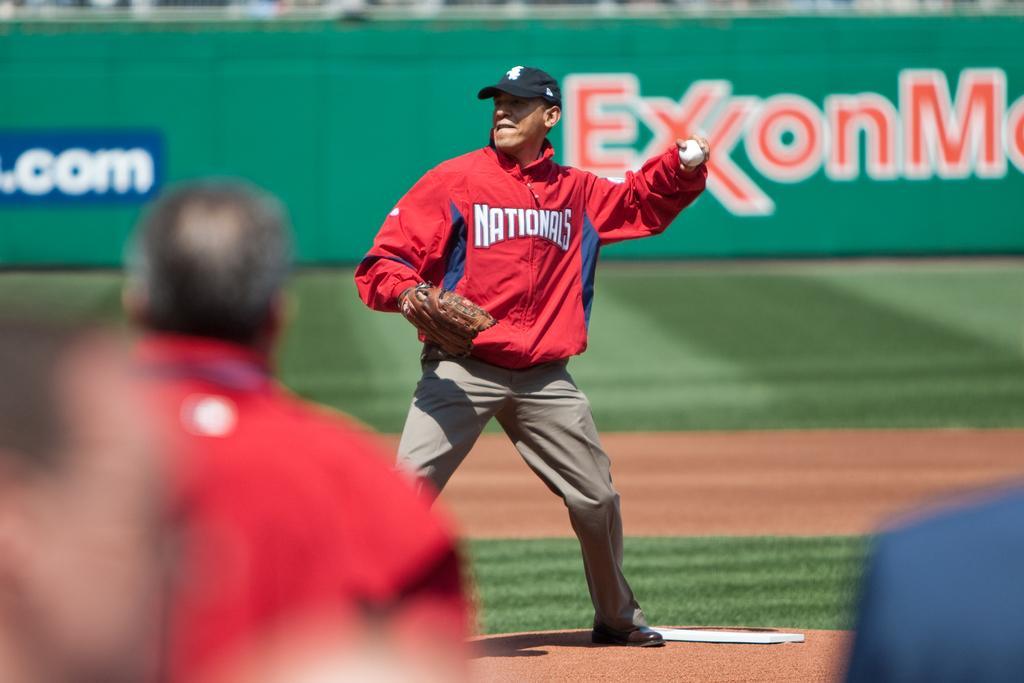How would you summarize this image in a sentence or two? In the picture we can see a man standing in the playground and he is in a sportswear and caps and he is holding a ball and behind him we can see a wall with some advertisements on it and in front of him we can see some people are also standing with sportswear. 